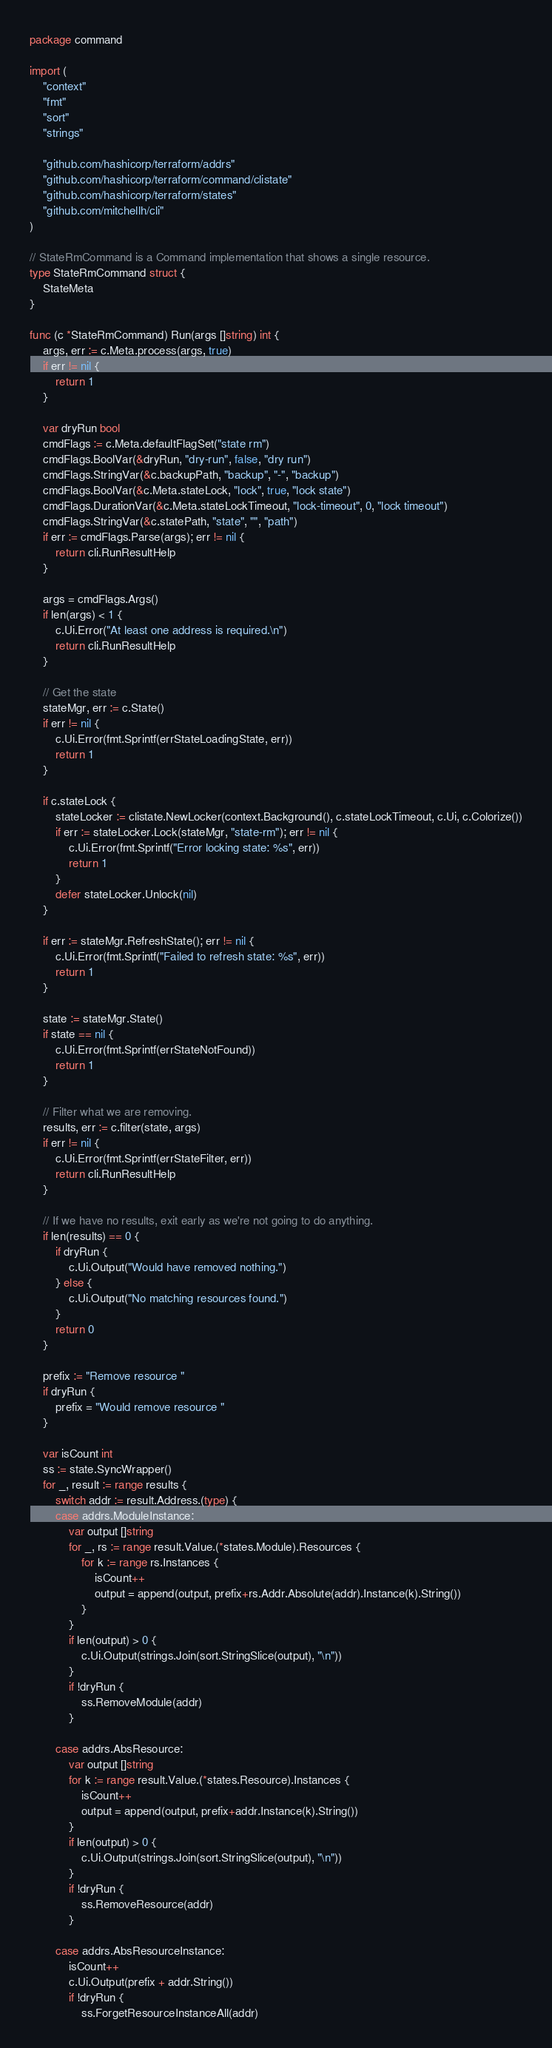Convert code to text. <code><loc_0><loc_0><loc_500><loc_500><_Go_>package command

import (
	"context"
	"fmt"
	"sort"
	"strings"

	"github.com/hashicorp/terraform/addrs"
	"github.com/hashicorp/terraform/command/clistate"
	"github.com/hashicorp/terraform/states"
	"github.com/mitchellh/cli"
)

// StateRmCommand is a Command implementation that shows a single resource.
type StateRmCommand struct {
	StateMeta
}

func (c *StateRmCommand) Run(args []string) int {
	args, err := c.Meta.process(args, true)
	if err != nil {
		return 1
	}

	var dryRun bool
	cmdFlags := c.Meta.defaultFlagSet("state rm")
	cmdFlags.BoolVar(&dryRun, "dry-run", false, "dry run")
	cmdFlags.StringVar(&c.backupPath, "backup", "-", "backup")
	cmdFlags.BoolVar(&c.Meta.stateLock, "lock", true, "lock state")
	cmdFlags.DurationVar(&c.Meta.stateLockTimeout, "lock-timeout", 0, "lock timeout")
	cmdFlags.StringVar(&c.statePath, "state", "", "path")
	if err := cmdFlags.Parse(args); err != nil {
		return cli.RunResultHelp
	}

	args = cmdFlags.Args()
	if len(args) < 1 {
		c.Ui.Error("At least one address is required.\n")
		return cli.RunResultHelp
	}

	// Get the state
	stateMgr, err := c.State()
	if err != nil {
		c.Ui.Error(fmt.Sprintf(errStateLoadingState, err))
		return 1
	}

	if c.stateLock {
		stateLocker := clistate.NewLocker(context.Background(), c.stateLockTimeout, c.Ui, c.Colorize())
		if err := stateLocker.Lock(stateMgr, "state-rm"); err != nil {
			c.Ui.Error(fmt.Sprintf("Error locking state: %s", err))
			return 1
		}
		defer stateLocker.Unlock(nil)
	}

	if err := stateMgr.RefreshState(); err != nil {
		c.Ui.Error(fmt.Sprintf("Failed to refresh state: %s", err))
		return 1
	}

	state := stateMgr.State()
	if state == nil {
		c.Ui.Error(fmt.Sprintf(errStateNotFound))
		return 1
	}

	// Filter what we are removing.
	results, err := c.filter(state, args)
	if err != nil {
		c.Ui.Error(fmt.Sprintf(errStateFilter, err))
		return cli.RunResultHelp
	}

	// If we have no results, exit early as we're not going to do anything.
	if len(results) == 0 {
		if dryRun {
			c.Ui.Output("Would have removed nothing.")
		} else {
			c.Ui.Output("No matching resources found.")
		}
		return 0
	}

	prefix := "Remove resource "
	if dryRun {
		prefix = "Would remove resource "
	}

	var isCount int
	ss := state.SyncWrapper()
	for _, result := range results {
		switch addr := result.Address.(type) {
		case addrs.ModuleInstance:
			var output []string
			for _, rs := range result.Value.(*states.Module).Resources {
				for k := range rs.Instances {
					isCount++
					output = append(output, prefix+rs.Addr.Absolute(addr).Instance(k).String())
				}
			}
			if len(output) > 0 {
				c.Ui.Output(strings.Join(sort.StringSlice(output), "\n"))
			}
			if !dryRun {
				ss.RemoveModule(addr)
			}

		case addrs.AbsResource:
			var output []string
			for k := range result.Value.(*states.Resource).Instances {
				isCount++
				output = append(output, prefix+addr.Instance(k).String())
			}
			if len(output) > 0 {
				c.Ui.Output(strings.Join(sort.StringSlice(output), "\n"))
			}
			if !dryRun {
				ss.RemoveResource(addr)
			}

		case addrs.AbsResourceInstance:
			isCount++
			c.Ui.Output(prefix + addr.String())
			if !dryRun {
				ss.ForgetResourceInstanceAll(addr)</code> 